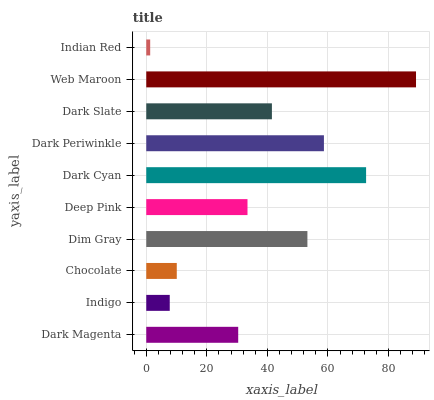Is Indian Red the minimum?
Answer yes or no. Yes. Is Web Maroon the maximum?
Answer yes or no. Yes. Is Indigo the minimum?
Answer yes or no. No. Is Indigo the maximum?
Answer yes or no. No. Is Dark Magenta greater than Indigo?
Answer yes or no. Yes. Is Indigo less than Dark Magenta?
Answer yes or no. Yes. Is Indigo greater than Dark Magenta?
Answer yes or no. No. Is Dark Magenta less than Indigo?
Answer yes or no. No. Is Dark Slate the high median?
Answer yes or no. Yes. Is Deep Pink the low median?
Answer yes or no. Yes. Is Web Maroon the high median?
Answer yes or no. No. Is Dark Magenta the low median?
Answer yes or no. No. 